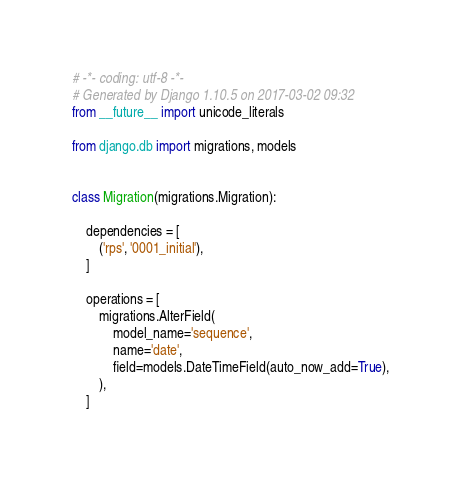<code> <loc_0><loc_0><loc_500><loc_500><_Python_># -*- coding: utf-8 -*-
# Generated by Django 1.10.5 on 2017-03-02 09:32
from __future__ import unicode_literals

from django.db import migrations, models


class Migration(migrations.Migration):

    dependencies = [
        ('rps', '0001_initial'),
    ]

    operations = [
        migrations.AlterField(
            model_name='sequence',
            name='date',
            field=models.DateTimeField(auto_now_add=True),
        ),
    ]
</code> 